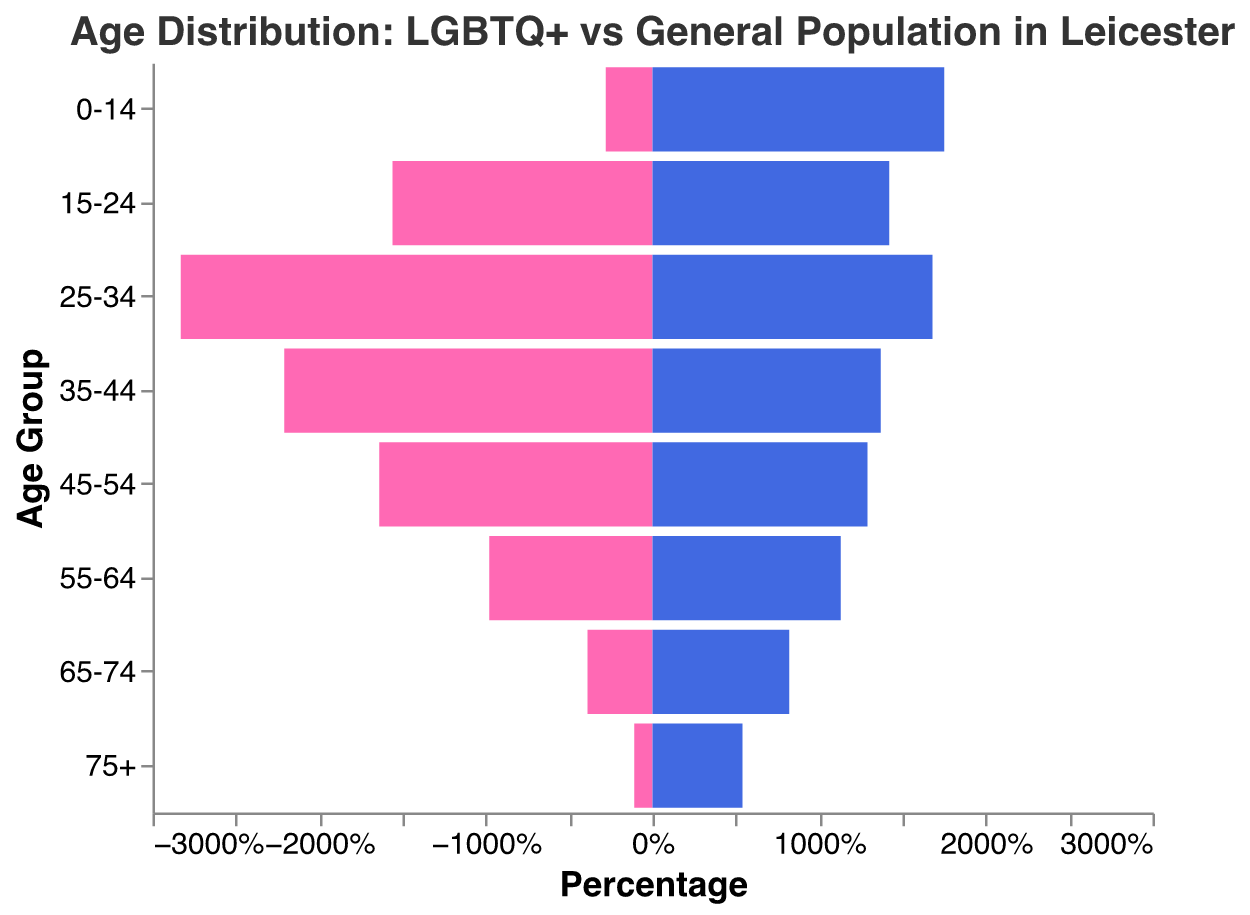What's the main color used to represent the LGBTQ+ population in the plot? The plot uses color to distinguish between the LGBTQ+ population and the general population. The LGBTQ+ population is represented by the color pink.
Answer: Pink What age group has the highest percentage in the LGBTQ+ population? To determine the age group with the highest percentage in the LGBTQ+ population, we can see which bar extends the farthest to the left. The 25-34 age group has the highest percentage.
Answer: 25-34 What's the difference in percentage between the LGBTQ+ and general population in the 0-14 age group? For the 0-14 age group, the LGBTQ+ population percentage is 2.8%, and the general population percentage is 17.5%. The difference is 17.5% - 2.8% = 14.7%.
Answer: 14.7% Explain how the LGBTQ+ population distribution compares to the general population in older age groups (65+) To compare the distribution in older age groups, we look at the percentages for age groups 65-74 and 75+. For 65-74, the LGBTQ+ population is 3.9%, and the general population is 8.2%. For 75+, the LGBTQ+ population is 1.1%, and the general population is 5.4%. The LGBTQ+ population is significantly lower in both older age groups.
Answer: Significantly lower Which population has a higher percentage in the 55-64 age group? Observing the bars corresponding to the 55-64 age group, the LGBTQ+ population has a percentage of 9.8%, whereas the general population has 11.3%. Therefore, the general population has a higher percentage in this age group.
Answer: General population What is the sum of percentages for the 25-34 and 35-44 age groups in the LGBTQ+ population? For the 25-34 age group, the percentage is 28.3%, and for the 35-44 age group, it is 22.1%. The sum is 28.3% + 22.1% = 50.4%.
Answer: 50.4% In which age group is the percentage of the general population closest to that of the LGBTQ+ population? To find the age group where percentages are closest, we compare the differences: for 0-14 (14.7), 15-24 (1.4), 25-34 (11.5), 35-44 (8.4), 45-54 (3.5), 55-64 (1.5), 65-74 (4.3), 75+ (4.3). The smallest difference is 1.4% for the 15-24 age group.
Answer: 15-24 Is there any age group where the LGBTQ+ population exceeds 20%? Checking the percentages for the LGBTQ+ population, the 25-34 (28.3%) and 35-44 (22.1%) age groups both exceed 20%.
Answer: Yes How does the percentage of the LGBTQ+ population in the 45-54 age group compare to the general population in the same group? For the 45-54 age group, the LGBTQ+ population percentage is 16.4%, and the general population percentage is 12.9%. The LGBTQ+ population has a higher percentage in this age group.
Answer: Higher 